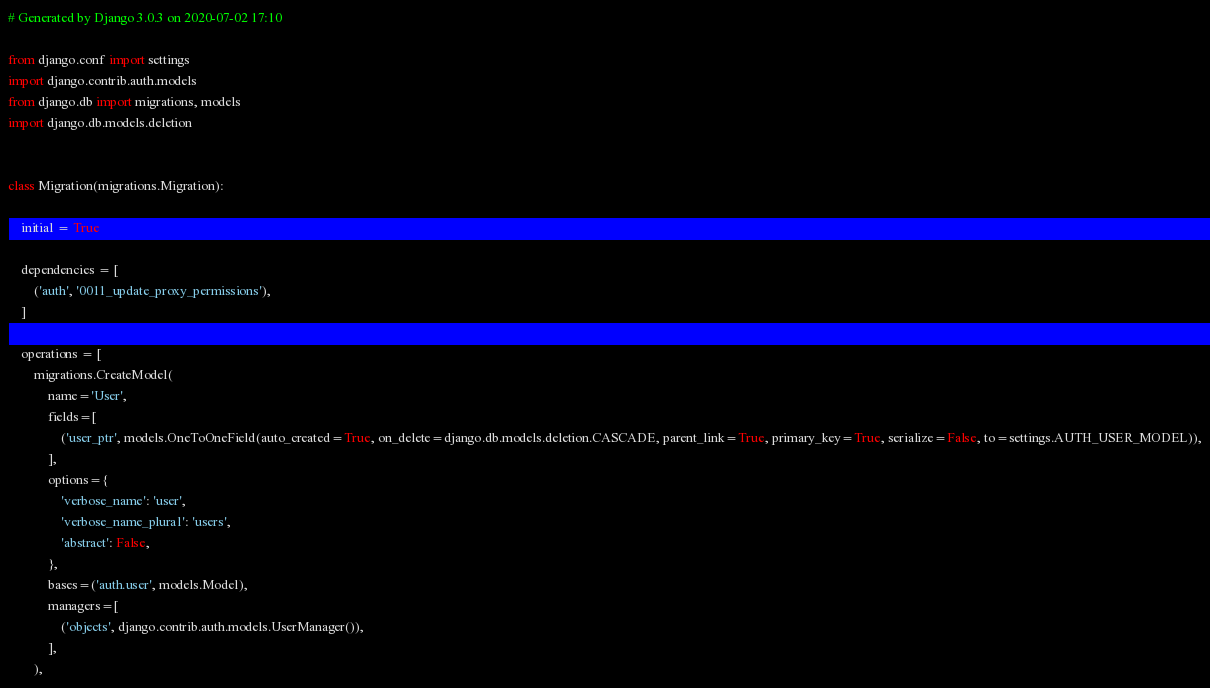Convert code to text. <code><loc_0><loc_0><loc_500><loc_500><_Python_># Generated by Django 3.0.3 on 2020-07-02 17:10

from django.conf import settings
import django.contrib.auth.models
from django.db import migrations, models
import django.db.models.deletion


class Migration(migrations.Migration):

    initial = True

    dependencies = [
        ('auth', '0011_update_proxy_permissions'),
    ]

    operations = [
        migrations.CreateModel(
            name='User',
            fields=[
                ('user_ptr', models.OneToOneField(auto_created=True, on_delete=django.db.models.deletion.CASCADE, parent_link=True, primary_key=True, serialize=False, to=settings.AUTH_USER_MODEL)),
            ],
            options={
                'verbose_name': 'user',
                'verbose_name_plural': 'users',
                'abstract': False,
            },
            bases=('auth.user', models.Model),
            managers=[
                ('objects', django.contrib.auth.models.UserManager()),
            ],
        ),</code> 